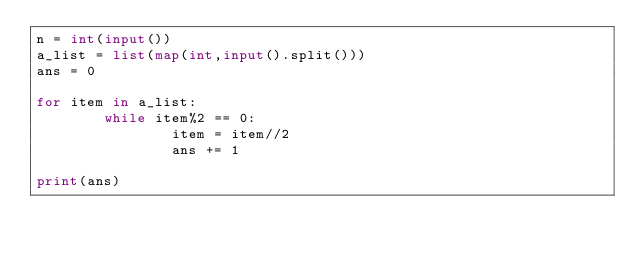<code> <loc_0><loc_0><loc_500><loc_500><_Python_>n = int(input())
a_list = list(map(int,input().split()))
ans = 0

for item in a_list:
        while item%2 == 0:
                item = item//2
                ans += 1
        
print(ans)
</code> 